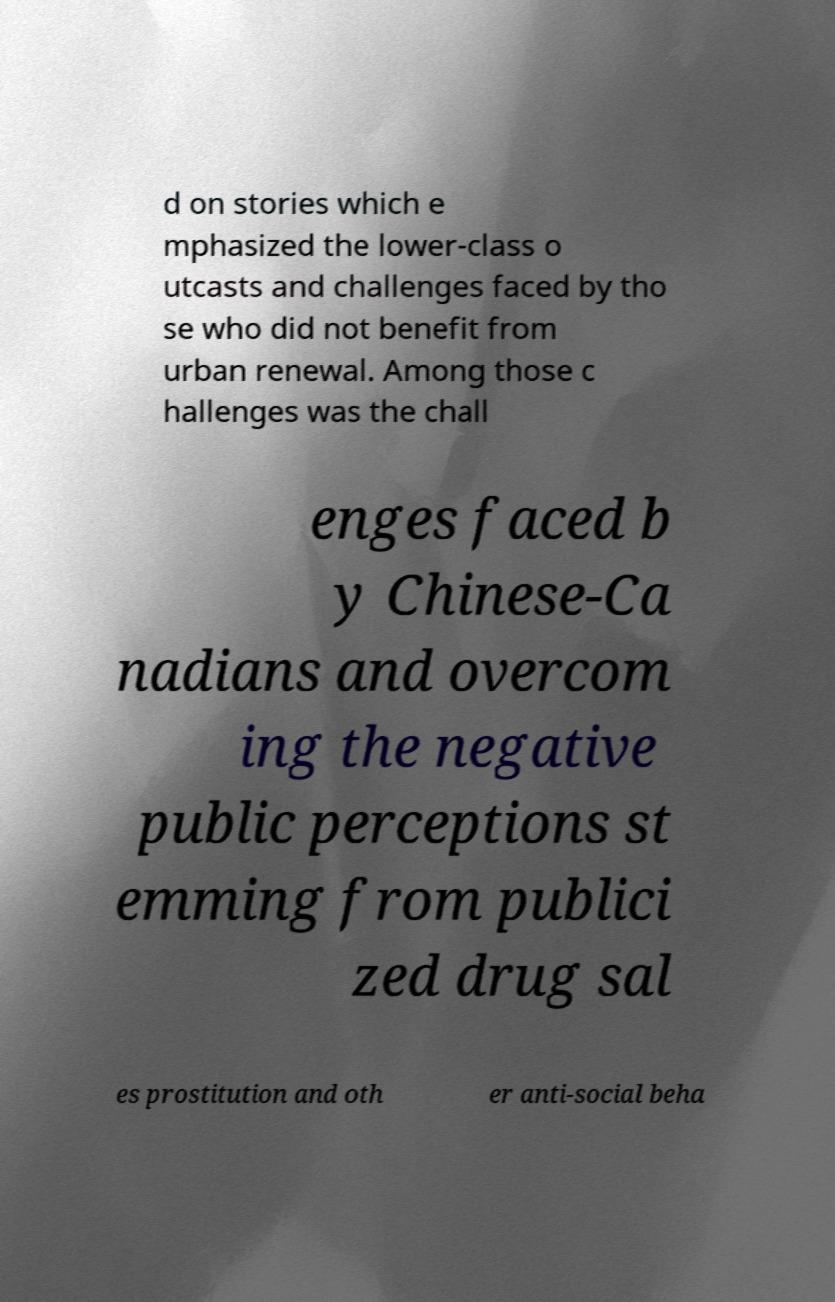Could you assist in decoding the text presented in this image and type it out clearly? d on stories which e mphasized the lower-class o utcasts and challenges faced by tho se who did not benefit from urban renewal. Among those c hallenges was the chall enges faced b y Chinese-Ca nadians and overcom ing the negative public perceptions st emming from publici zed drug sal es prostitution and oth er anti-social beha 